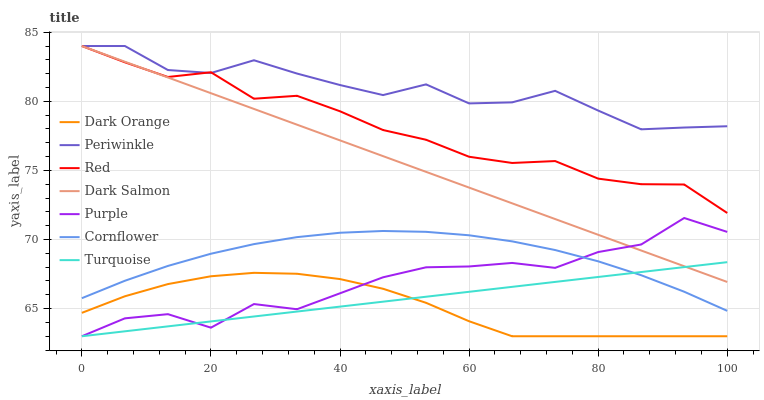Does Dark Orange have the minimum area under the curve?
Answer yes or no. Yes. Does Periwinkle have the maximum area under the curve?
Answer yes or no. Yes. Does Turquoise have the minimum area under the curve?
Answer yes or no. No. Does Turquoise have the maximum area under the curve?
Answer yes or no. No. Is Dark Salmon the smoothest?
Answer yes or no. Yes. Is Purple the roughest?
Answer yes or no. Yes. Is Turquoise the smoothest?
Answer yes or no. No. Is Turquoise the roughest?
Answer yes or no. No. Does Dark Orange have the lowest value?
Answer yes or no. Yes. Does Cornflower have the lowest value?
Answer yes or no. No. Does Red have the highest value?
Answer yes or no. Yes. Does Turquoise have the highest value?
Answer yes or no. No. Is Dark Orange less than Dark Salmon?
Answer yes or no. Yes. Is Red greater than Cornflower?
Answer yes or no. Yes. Does Turquoise intersect Dark Orange?
Answer yes or no. Yes. Is Turquoise less than Dark Orange?
Answer yes or no. No. Is Turquoise greater than Dark Orange?
Answer yes or no. No. Does Dark Orange intersect Dark Salmon?
Answer yes or no. No. 